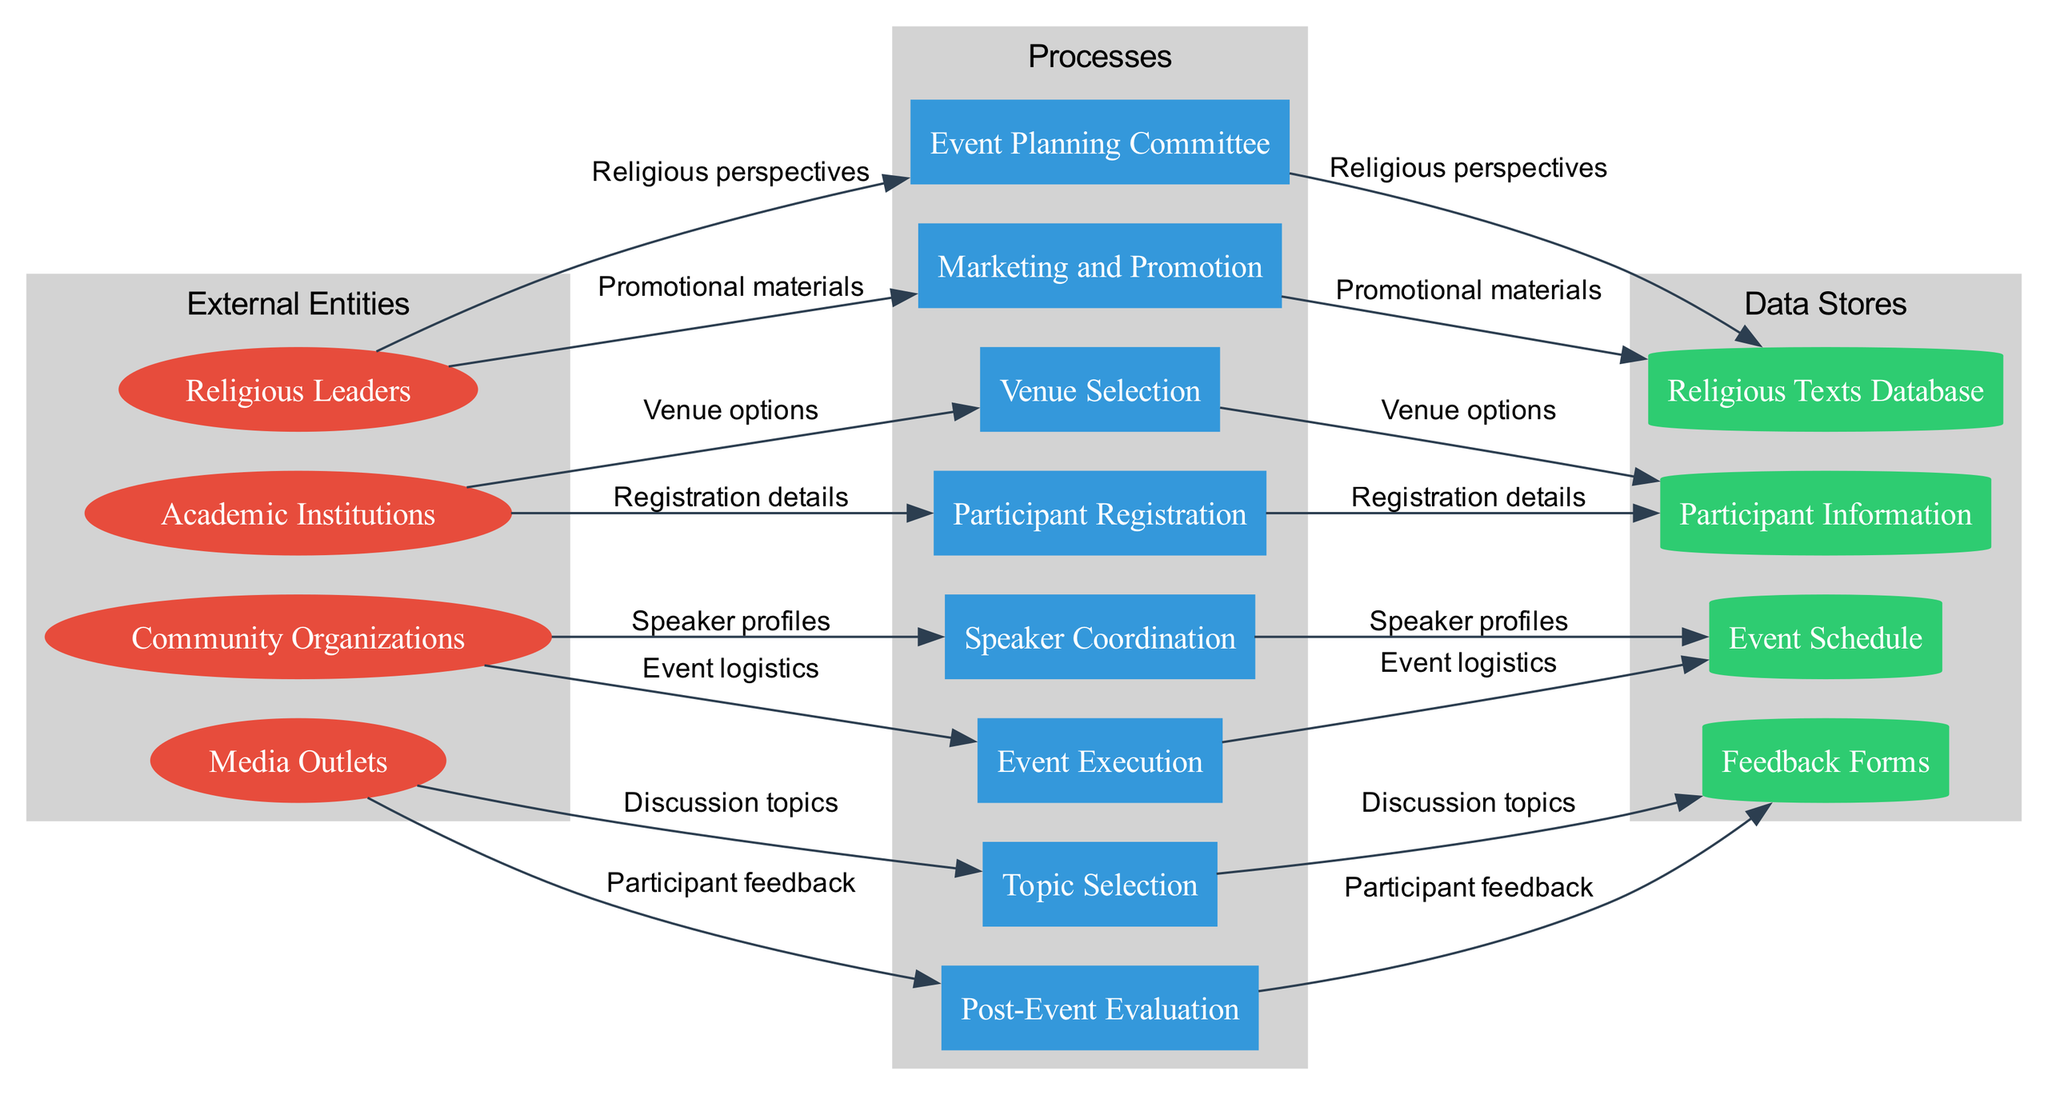What are the external entities involved? The diagram lists four external entities, which are Religious Leaders, Academic Institutions, Community Organizations, and Media Outlets.
Answer: Religious Leaders, Academic Institutions, Community Organizations, Media Outlets How many processes are there in the diagram? The diagram includes eight distinct processes related to event planning. Counting them gives us the total number of processes as eight.
Answer: Eight Which process is responsible for selecting the venue? In the diagram, the process labeled 'Venue Selection' is specifically responsible for choosing the venue for the interfaith dialogue event.
Answer: Venue Selection What is the primary output of the 'Participant Registration' process? The output of the 'Participant Registration' process is 'Registration details', which indicates the information collected about the participants.
Answer: Registration details Which external entity provides 'Speaker profiles' to the 'Speaker Coordination' process? The 'Speaker profiles' are provided by the external entity labeled 'Religious Leaders', who likely recommend speakers for the event.
Answer: Religious Leaders What is fed into the 'Marketing and Promotion' process? The input to the 'Marketing and Promotion' process comes from the 'Discussion topics' that need to be advertised and promoted to attract participants.
Answer: Discussion topics How many data flows connect to the 'Event Execution' process? Tracing the data flows, there are three distinct connections that lead into the 'Event Execution' process, indicating significant inputs for this stage.
Answer: Three What type of data is stored in the 'Feedback Forms' data store? The 'Feedback Forms' data store contains responses from participants after the event, which serves as a measure of success and areas for improvement.
Answer: Responses Which data flow originates from the 'Event Schedule' data store? The 'Event logistics' data flow stems from the 'Event Schedule' data store, detailing the plans and arrangements for executing the event effectively.
Answer: Event logistics 